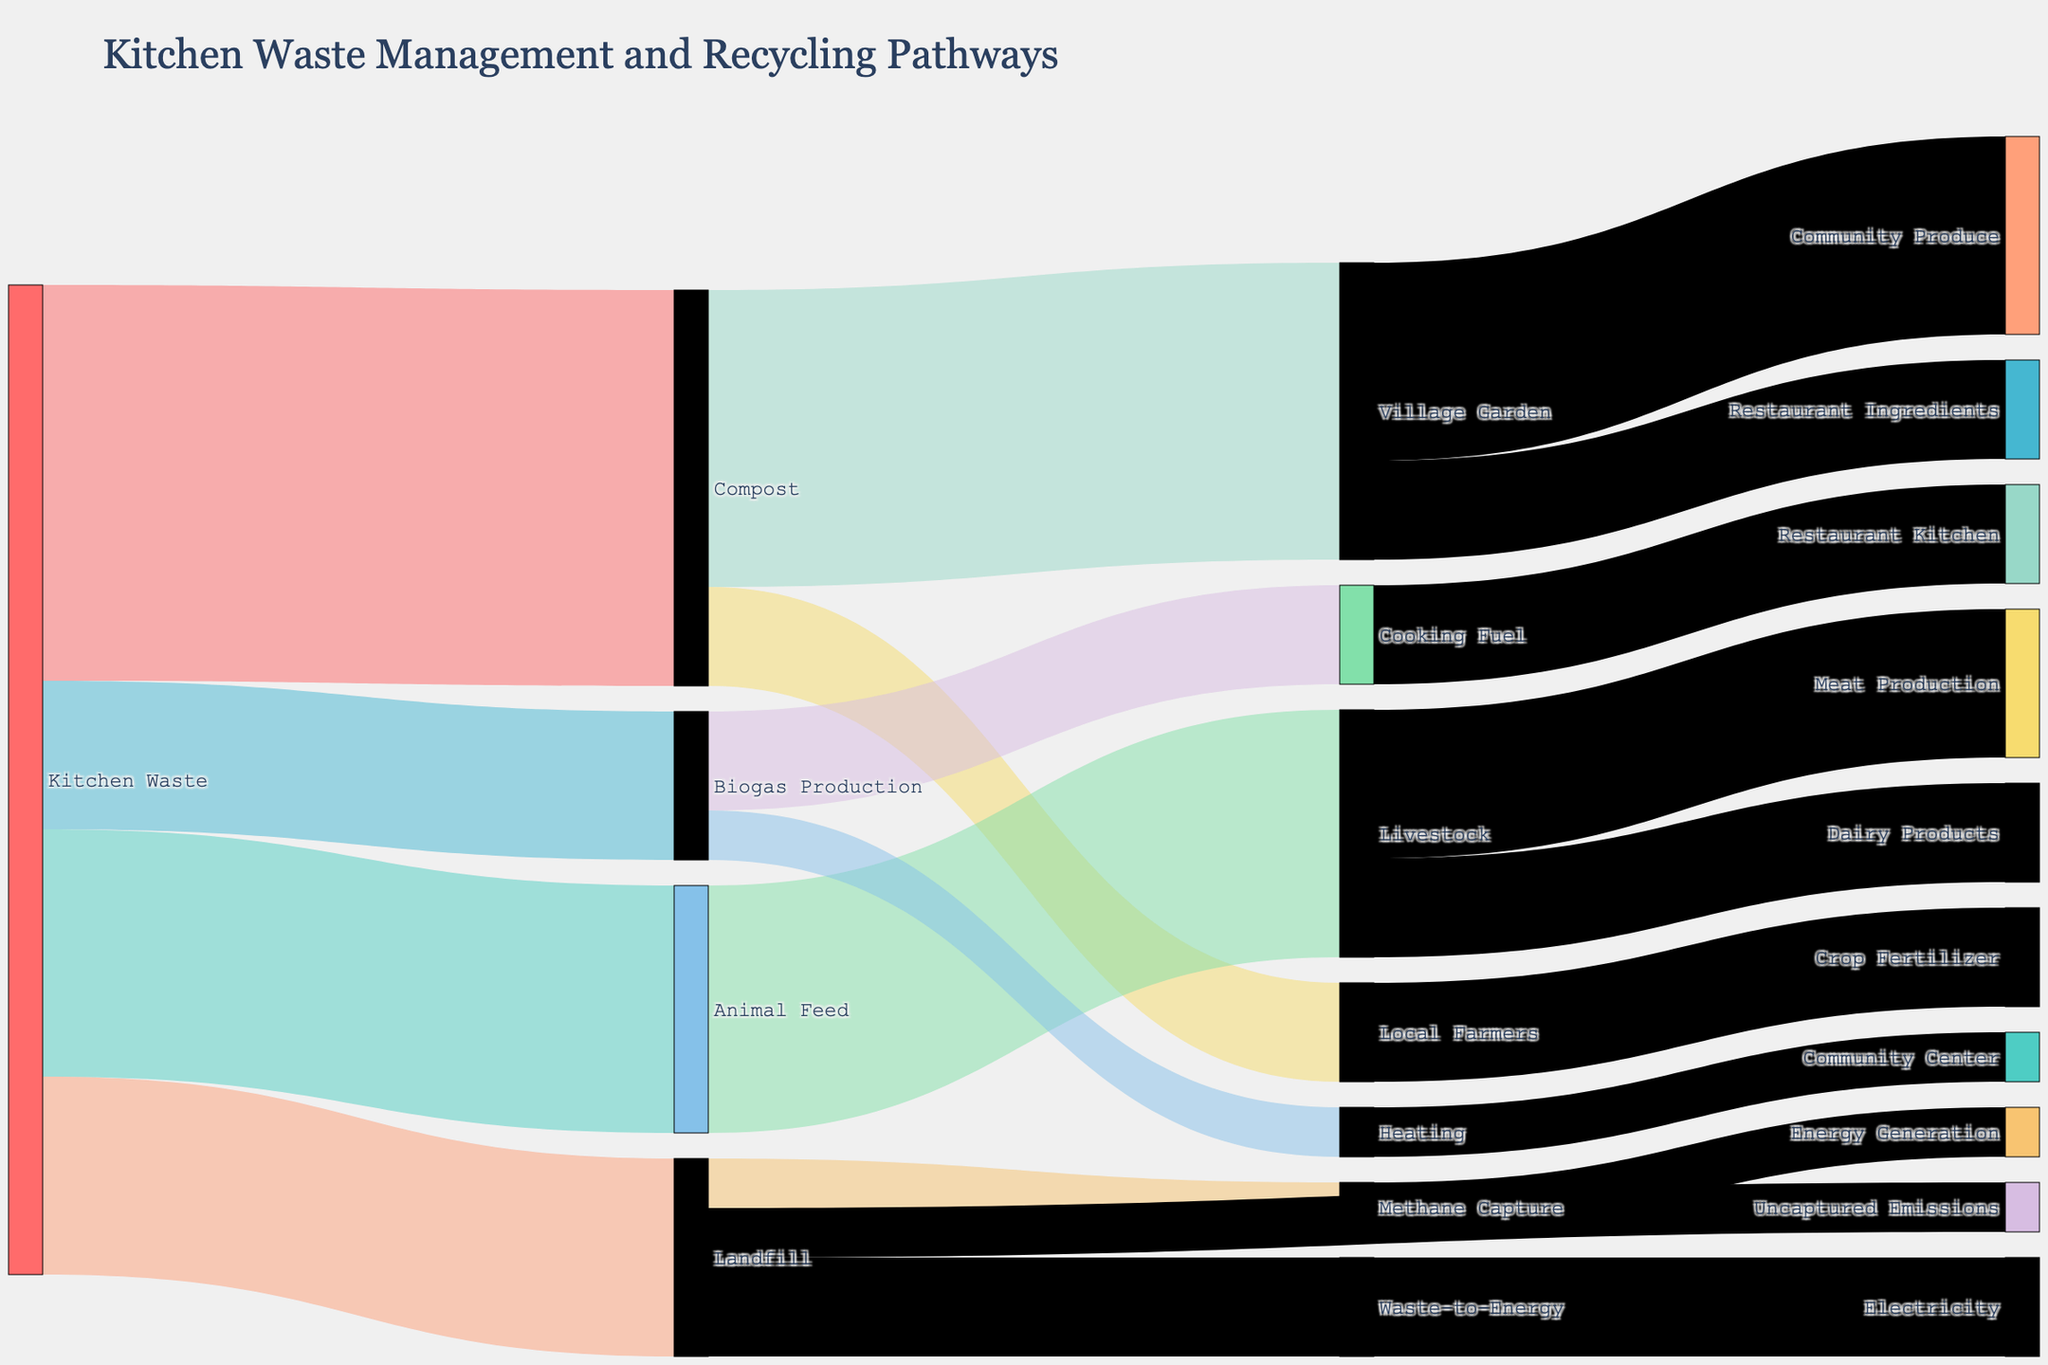what is the title of the figure? The title of the figure is displayed prominently at the top of the chart.
Answer: Kitchen Waste Management and Recycling Pathways Which pathway receives the highest amount of kitchen waste? By inspecting the values linked from "Kitchen Waste," we can see that "Compost" receives the highest amount at 40 units.
Answer: Compost How much kitchen waste goes to Biogas Production compared to Landfill? From the chart, "Biogas Production" receives 15 units and "Landfill" receives 20 units of kitchen waste. Subtracting these values gives the answer 20 - 15 = 5 units more go to Landfill.
Answer: 5 units more What is the total value of compost distributed to village garden and local farmers? Compost is split into two pathways: 30 units to "Village Garden" and 10 units to "Local Farmers". Summing these yields 30 + 10 = 40 units.
Answer: 40 units How much kitchen waste is converted into animal feed? The value associated with the pathway from "Kitchen Waste" to "Animal Feed" is 25 units.
Answer: 25 units Which pathway produces more energy, biogas production or waste-to-energy from landfill? Looking at both "Biogas Production" and "Waste-to-Energy" pathways, "Biogas Production" contributes to "Cooking Fuel" (10 units) and "Heating" (5 units) for a total of 15 units. Waste-to-energy from landfill contributes 10 units. Hence, biogas production produces more energy.
Answer: Biogas Production Is there any emission that is not captured from the landfill? The flow to "Uncaptured Emissions" from "Landfill" shows 5 units of emissions that are not captured.
Answer: Yes, 5 units What is the value associated with methane capture from the landfill? The methane capture pathway from "Landfill" shows a value of 5 units.
Answer: 5 units What proportion of kitchen waste is converted into compost? The chart shows that 40 units from "Kitchen Waste" are converted into "Compost" out of a total of 100 units of kitchen waste, so the proportion is 40/100 = 40%.
Answer: 40% How much of the biogas production is used for cooking fuel? The pathway from "Biogas Production" to "Cooking Fuel" shows a value of 10 units.
Answer: 10 units 